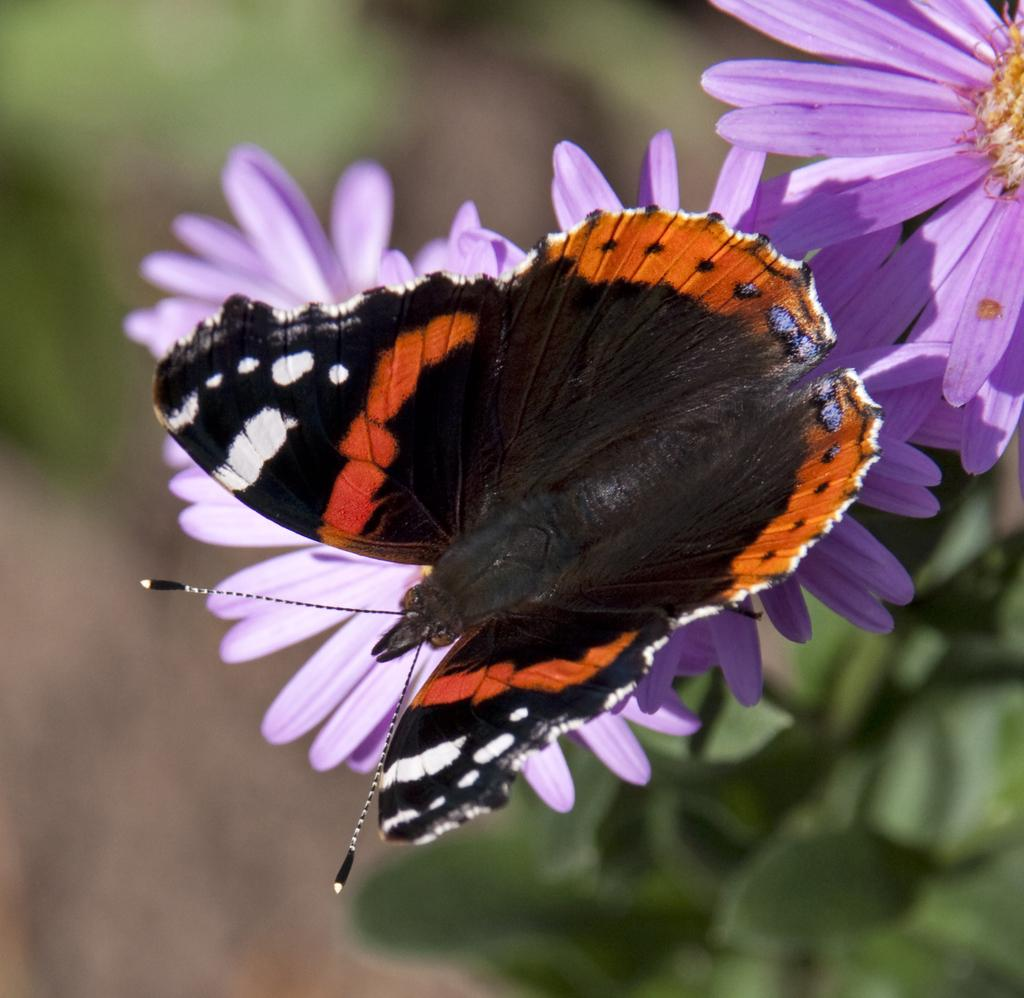What is the main subject in the middle of the image? There is a butterfly in the middle of the image. What can be seen in the background of the image? There are flowers and green leaves in the background of the image. What type of disease is affecting the butterfly in the image? There is no indication of any disease affecting the butterfly in the image. 